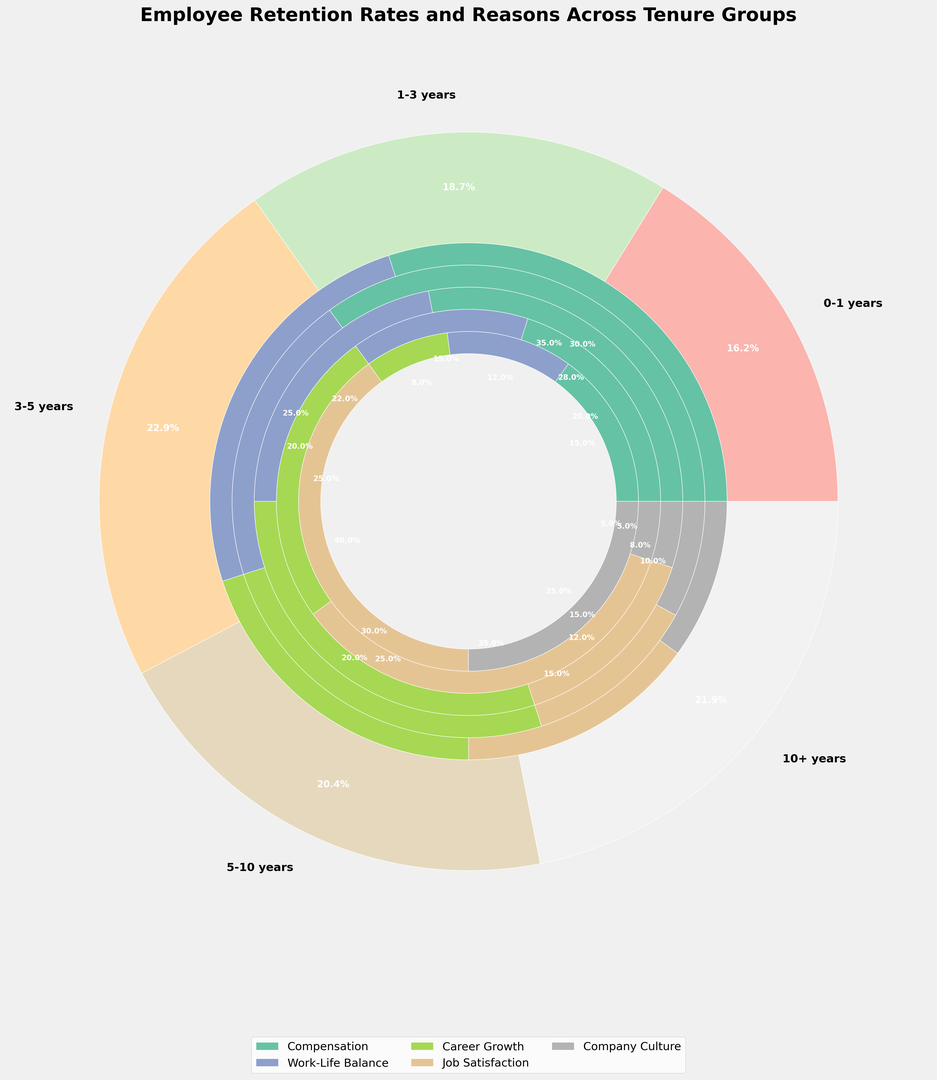What is the overall trend in retention rates as tenure increases? The outer pie chart shows retention rates for different tenure groups. By observing the chart, retention rates generally increase as tenure moves from 0-1 years to 10+ years. The percentages are 65%, 75%, 82%, 88%, and 92% respectively.
Answer: Retention rates increase with tenure Which tenure group has the highest retention rate? Observing the outer pie chart, the 10+ years tenure group has the highest retention rate of 92%.
Answer: 10+ years In the 0-1 years tenure group, what is the most common reason for retention? In the inner pie chart corresponding to the 0-1 years tenure group, the largest segment is labeled "Compensation," representing 30%.
Answer: Compensation How does the importance of "Job Satisfaction" change as tenure increases from 0-1 years to 10+ years? By examining the inner segments for each tenure group, "Job Satisfaction" starts at 15% for 0-1 years, 12% for 1-3 years, 15% for 3-5 years, 35% for 5-10 years, and 40% for 10+ years, showing a clear increase with rising tenure.
Answer: It increases Compare the importance of "Career Growth" between the 1-3 years and the 5-10 years tenure groups. Looking at the inner pie charts for these tenure ranges, "Career Growth" is 25% for 1-3 years and 25% for 5-10 years, indicating equal importance in these two groups.
Answer: Equal Calculate the combined percentage for "Compensation" and "Career Growth" for the 3-5 years tenure group. From the inner pie chart segments for 3-5 years, "Compensation" is 28% and "Career Growth" is 30%. Summing these values, 28% + 30% = 58%.
Answer: 58% Which reason has the smallest percentage in the 10+ years tenure group? In the inner pie segment for 10+ years, the smallest segment is "Career Growth" with 8%.
Answer: Career Growth What is the difference in the percentage for "Work-Life Balance" between the 0-1 years and 1-3 years tenure groups? "Work-Life Balance" is 25% for 0-1 years and 20% for 1-3 years. The difference is 25% - 20% = 5%.
Answer: 5% Which factor is consistently one of the top two reasons for retention across all tenure groups? By inspecting all inner pie chart segments, "Compensation" frequently appears as one of the top two reasons for retention across all tenure groups.
Answer: Compensation 